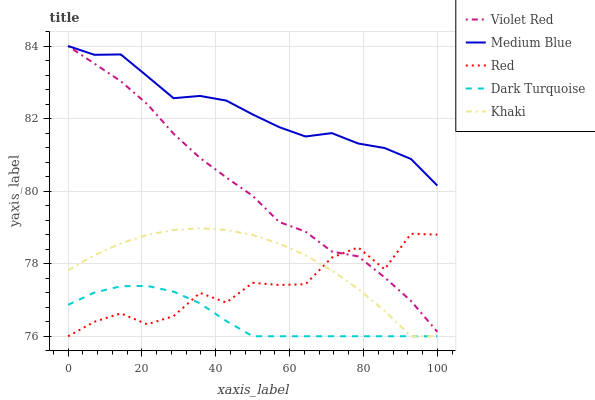Does Dark Turquoise have the minimum area under the curve?
Answer yes or no. Yes. Does Medium Blue have the maximum area under the curve?
Answer yes or no. Yes. Does Violet Red have the minimum area under the curve?
Answer yes or no. No. Does Violet Red have the maximum area under the curve?
Answer yes or no. No. Is Dark Turquoise the smoothest?
Answer yes or no. Yes. Is Red the roughest?
Answer yes or no. Yes. Is Violet Red the smoothest?
Answer yes or no. No. Is Violet Red the roughest?
Answer yes or no. No. Does Dark Turquoise have the lowest value?
Answer yes or no. Yes. Does Violet Red have the lowest value?
Answer yes or no. No. Does Medium Blue have the highest value?
Answer yes or no. Yes. Does Khaki have the highest value?
Answer yes or no. No. Is Khaki less than Medium Blue?
Answer yes or no. Yes. Is Violet Red greater than Khaki?
Answer yes or no. Yes. Does Red intersect Violet Red?
Answer yes or no. Yes. Is Red less than Violet Red?
Answer yes or no. No. Is Red greater than Violet Red?
Answer yes or no. No. Does Khaki intersect Medium Blue?
Answer yes or no. No. 